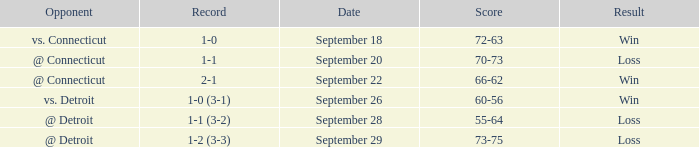What is the date with score of 66-62? September 22. 